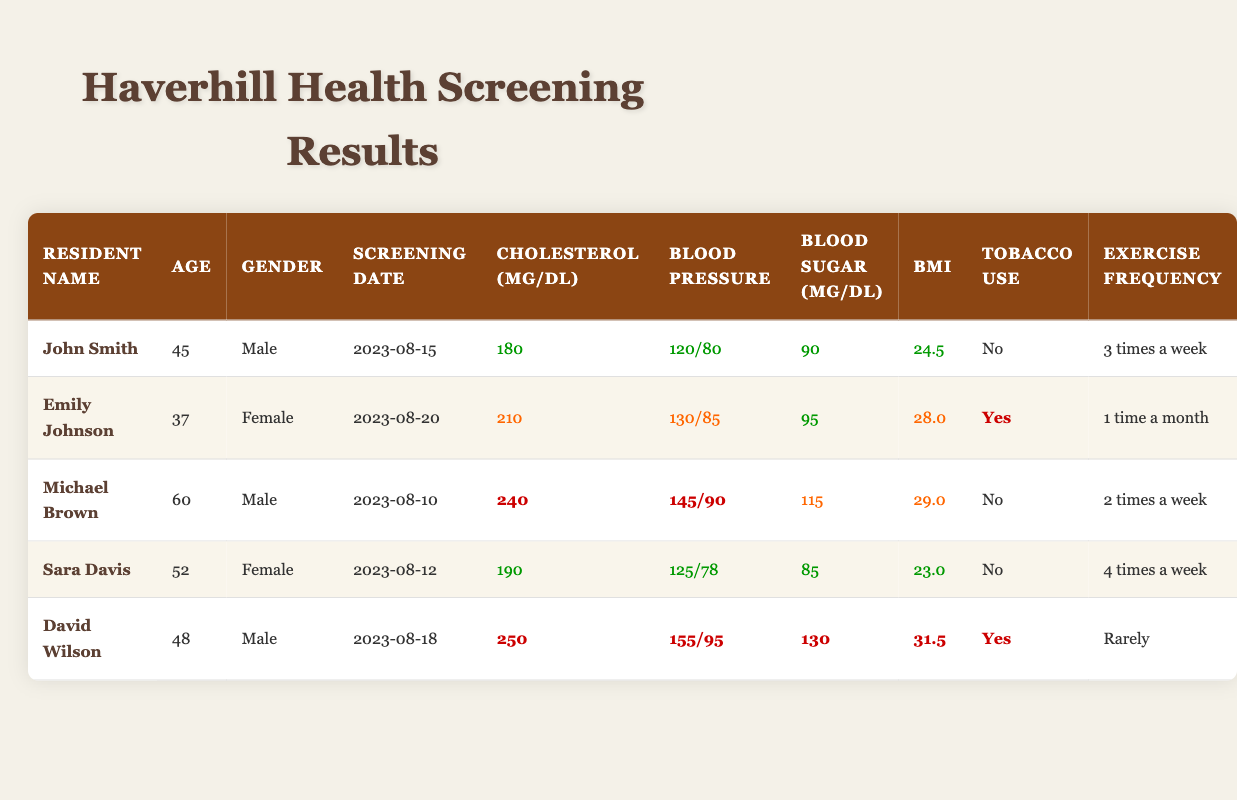What is the cholesterol level of Sara Davis? From the table, we see that Sara Davis has a cholesterol level of 190 mg/dL listed under her health screening results.
Answer: 190 mg/dL How many residents reported tobacco use? In the table, when looking at the "Tobacco Use" column, we find that Emily Johnson and David Wilson reported using tobacco, totaling 2 residents.
Answer: 2 What is the average body mass index (BMI) of the residents? To find the average BMI, we add all the BMI values: (24.5 + 28.0 + 29.0 + 23.0 + 31.5) = 136.0. There are 5 residents, so dividing the total by 5 gives us 136.0 / 5 = 27.2.
Answer: 27.2 Is the blood pressure of Michael Brown considered high? Michael Brown's blood pressure reading is 145/90. According to general medical guidelines, a systolic reading of 140 or higher and/or a diastolic reading of 90 or higher is considered high. Therefore, it is classified as high.
Answer: Yes Which resident has the highest blood sugar level? Upon reviewing the "Blood Sugar (mg/dL)" column, we see that David Wilson has the highest level at 130 mg/dL compared to the other residents.
Answer: David Wilson How many residents exercise more than 2 times a week? Referring to the "Exercise Frequency" column, we note that only John Smith and Sara Davis exercise more than 2 times a week (3 times and 4 times respectively). Therefore, the total is 2 residents.
Answer: 2 What is the difference in cholesterol levels between Michael Brown and John Smith? Michael Brown's cholesterol level is 240 mg/dL, and John Smith's is 180 mg/dL. The difference can be calculated as 240 - 180 = 60 mg/dL.
Answer: 60 mg/dL Is Emily Johnson younger than 40 years old? Emily Johnson is 37 years old, which is indeed younger than 40 years old.
Answer: Yes What is the maximum blood pressure reading among the residents? Comparing the "Blood Pressure" values, David Wilson has the highest systolic reading of 155 and a diastolic reading of 95, which makes it the highest overall among the residents.
Answer: 155/95 